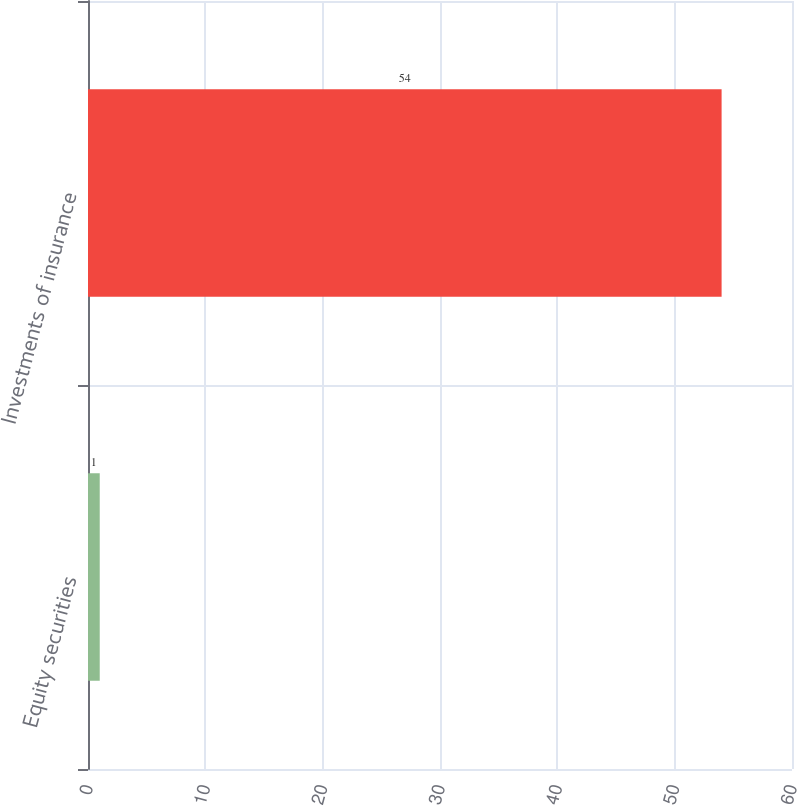<chart> <loc_0><loc_0><loc_500><loc_500><bar_chart><fcel>Equity securities<fcel>Investments of insurance<nl><fcel>1<fcel>54<nl></chart> 